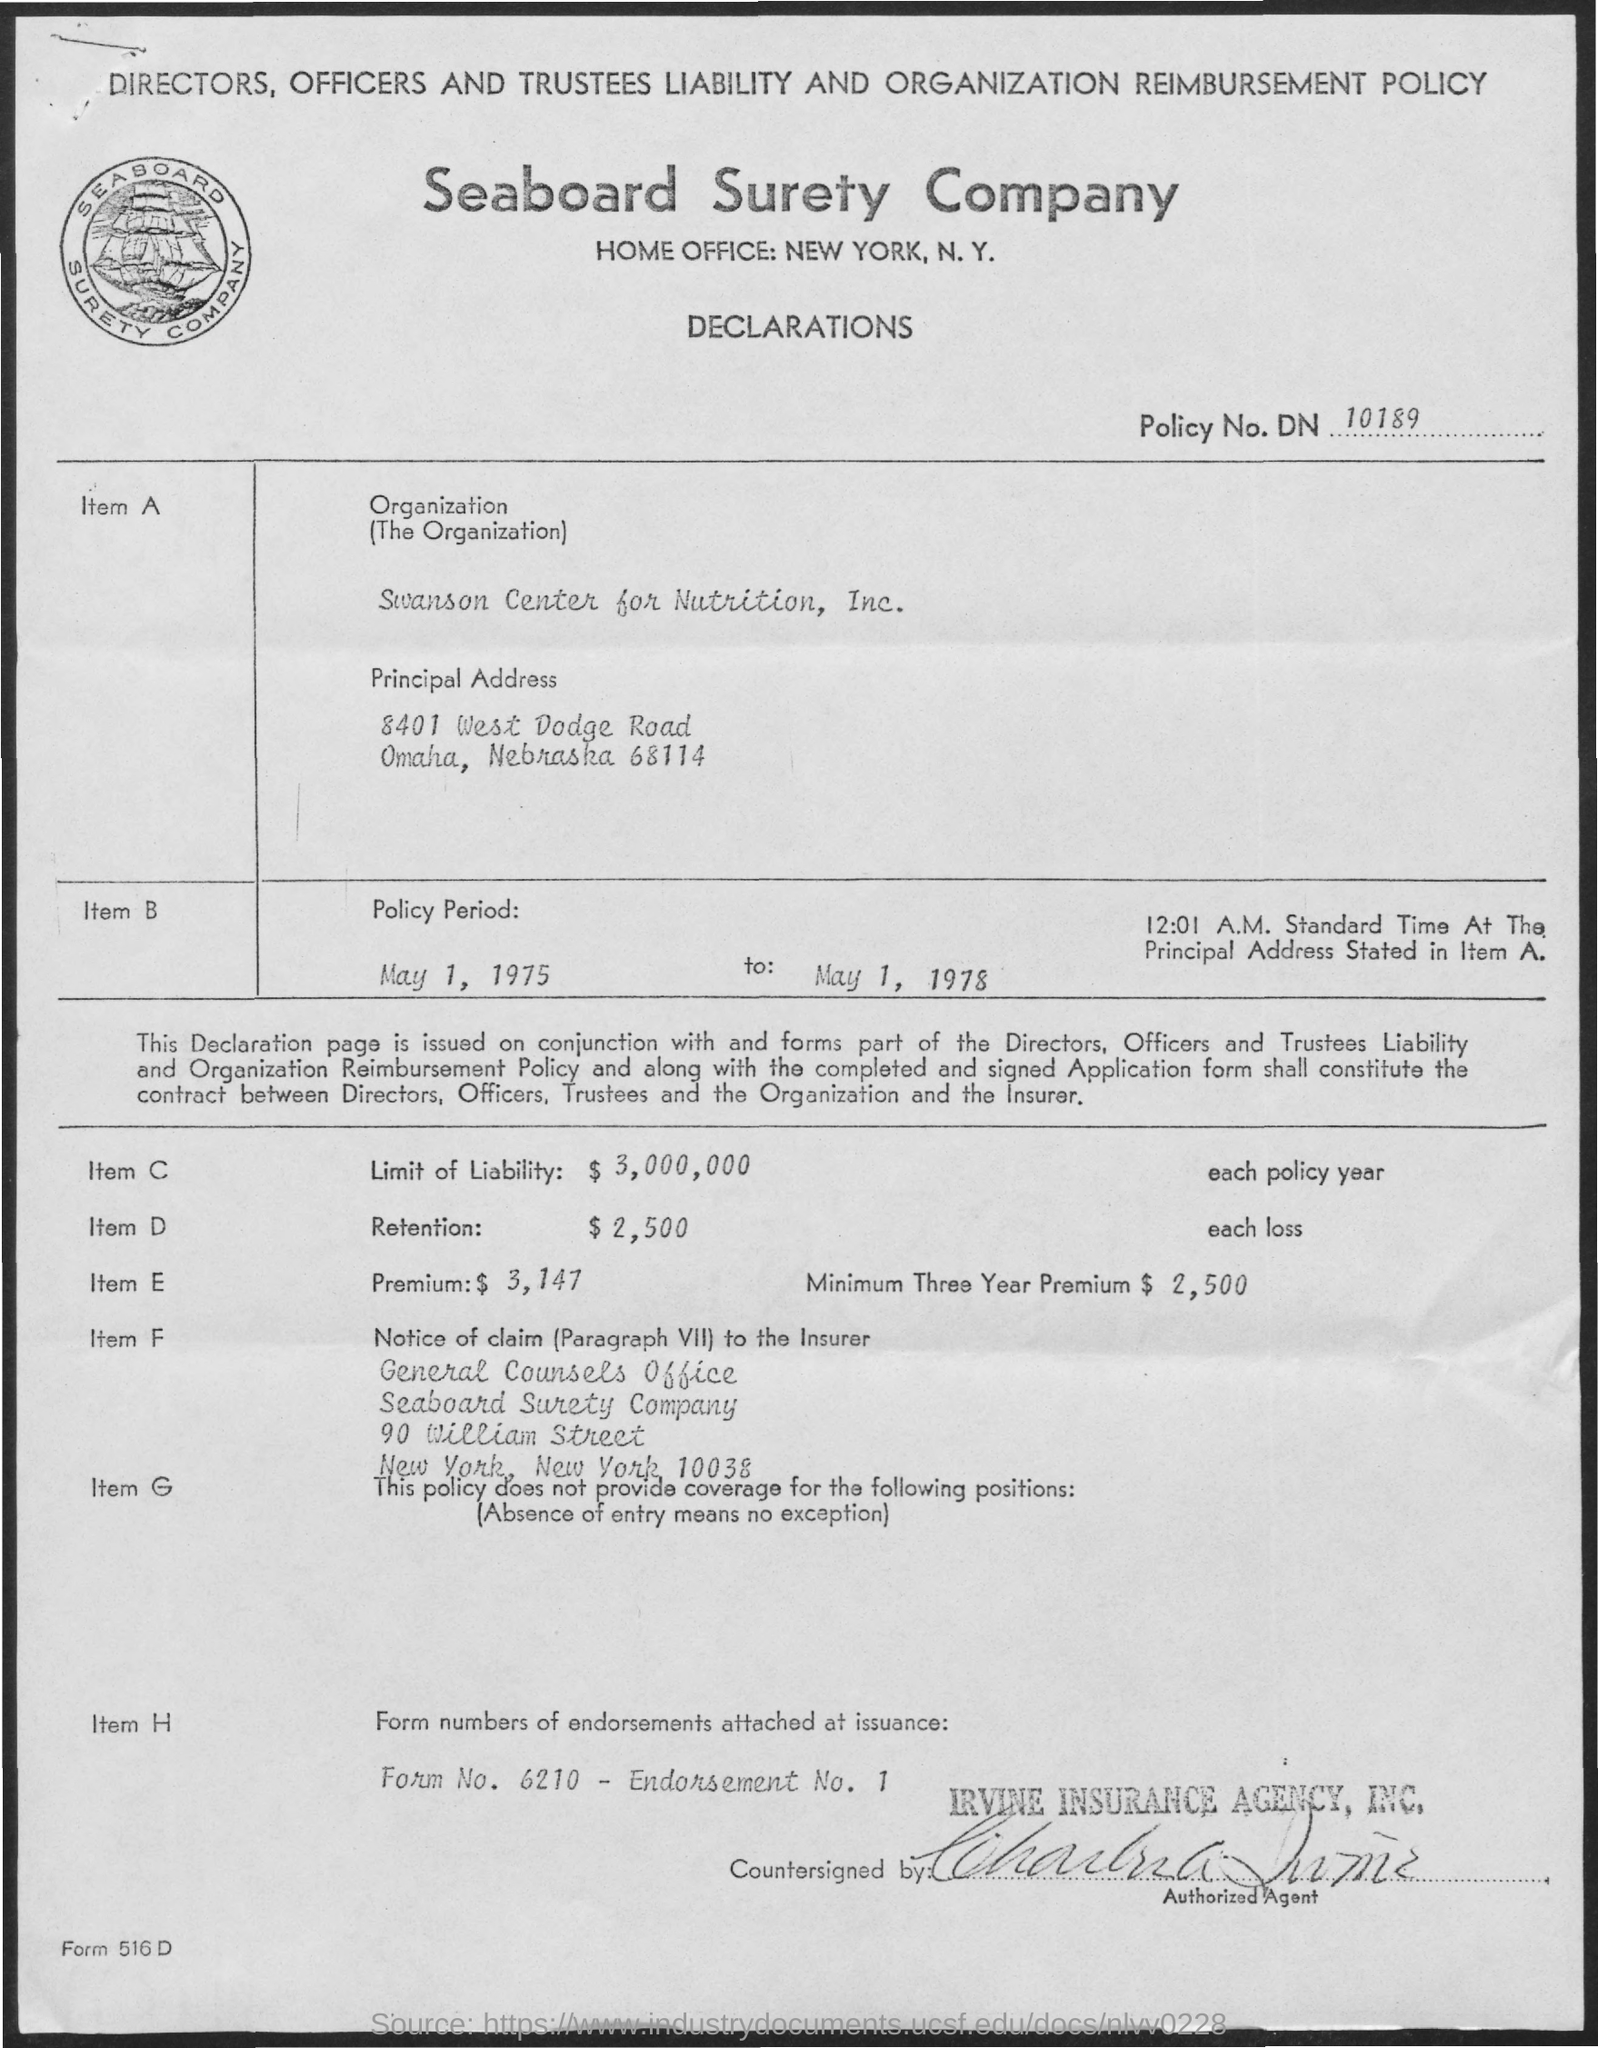What is the name of the company mentioned ?
Offer a very short reply. Seaboard surety company. What is the policy no. mentioned ?
Your answer should be compact. DN 10189. What is the policy period mentioned for item b?
Your answer should be compact. May 1, 1975 to may 1, 1978. What is the amount mentioned for limit of liability for item c?
Make the answer very short. $3,000,000. What is the amount mentioned for retention for item d?
Offer a very short reply. $ 2,500. What is the premium amount mentioned for item e?
Keep it short and to the point. $3,147. What is the amount mentioned for minimum three year premium for item e?
Your answer should be compact. $2,500. 